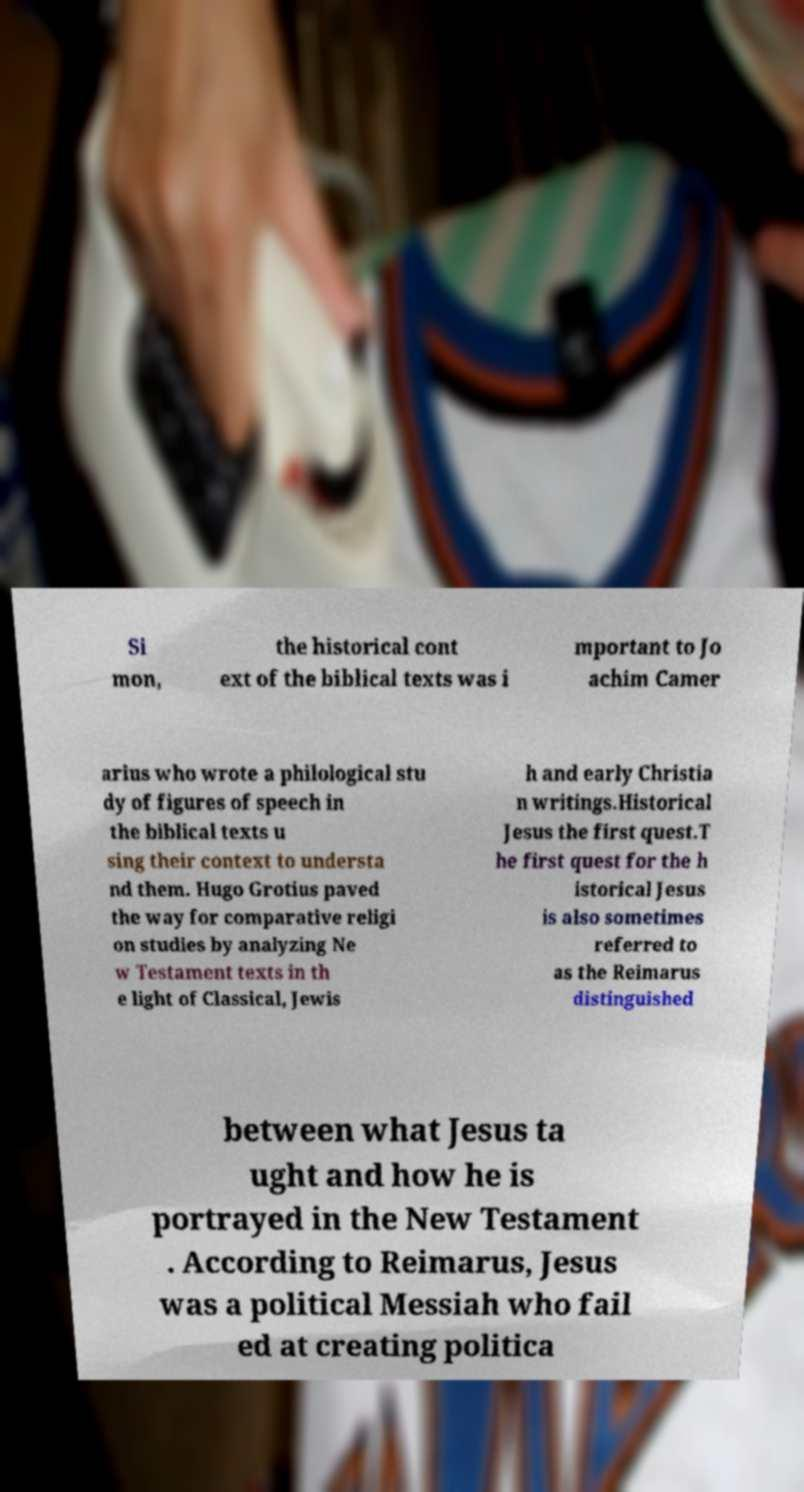Can you read and provide the text displayed in the image?This photo seems to have some interesting text. Can you extract and type it out for me? Si mon, the historical cont ext of the biblical texts was i mportant to Jo achim Camer arius who wrote a philological stu dy of figures of speech in the biblical texts u sing their context to understa nd them. Hugo Grotius paved the way for comparative religi on studies by analyzing Ne w Testament texts in th e light of Classical, Jewis h and early Christia n writings.Historical Jesus the first quest.T he first quest for the h istorical Jesus is also sometimes referred to as the Reimarus distinguished between what Jesus ta ught and how he is portrayed in the New Testament . According to Reimarus, Jesus was a political Messiah who fail ed at creating politica 